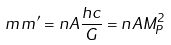Convert formula to latex. <formula><loc_0><loc_0><loc_500><loc_500>m \, m ^ { \prime } = n A \frac { h c } { G } = n A M _ { P } ^ { 2 }</formula> 